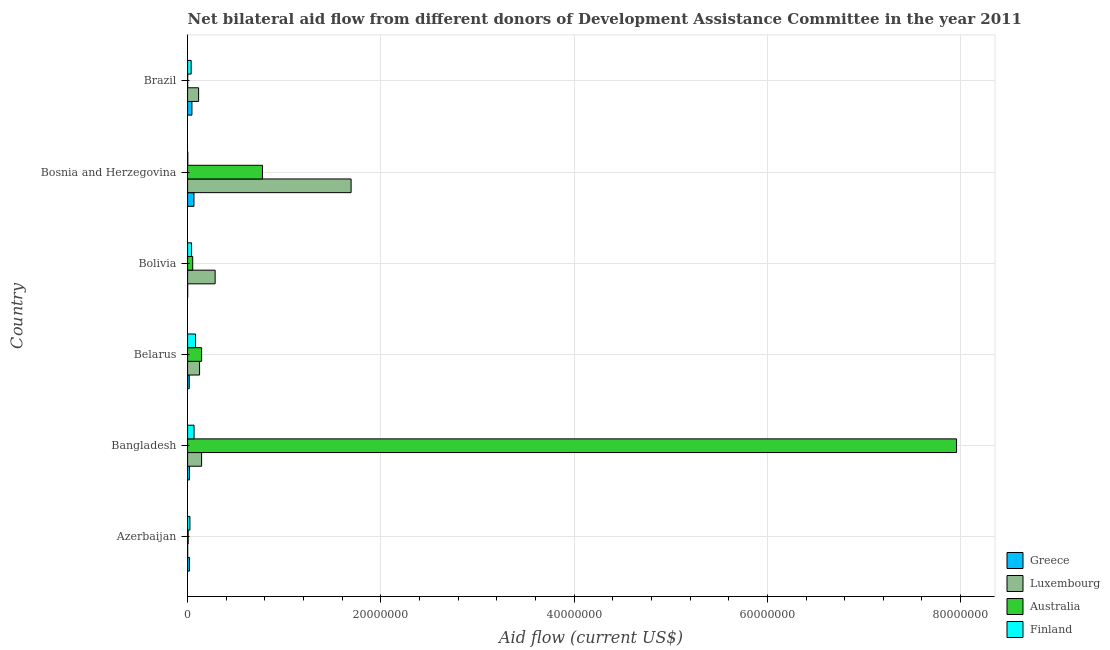How many groups of bars are there?
Your answer should be very brief. 6. Are the number of bars on each tick of the Y-axis equal?
Provide a succinct answer. Yes. How many bars are there on the 3rd tick from the top?
Keep it short and to the point. 4. How many bars are there on the 6th tick from the bottom?
Your response must be concise. 4. What is the label of the 5th group of bars from the top?
Provide a short and direct response. Bangladesh. In how many cases, is the number of bars for a given country not equal to the number of legend labels?
Ensure brevity in your answer.  0. What is the amount of aid given by luxembourg in Belarus?
Ensure brevity in your answer.  1.24e+06. Across all countries, what is the maximum amount of aid given by luxembourg?
Provide a succinct answer. 1.69e+07. Across all countries, what is the minimum amount of aid given by australia?
Ensure brevity in your answer.  10000. What is the total amount of aid given by luxembourg in the graph?
Your answer should be compact. 2.36e+07. What is the difference between the amount of aid given by finland in Bangladesh and that in Bosnia and Herzegovina?
Your answer should be compact. 6.50e+05. What is the difference between the amount of aid given by australia in Bosnia and Herzegovina and the amount of aid given by finland in Belarus?
Provide a succinct answer. 6.93e+06. What is the average amount of aid given by luxembourg per country?
Your response must be concise. 3.94e+06. What is the difference between the amount of aid given by luxembourg and amount of aid given by greece in Azerbaijan?
Ensure brevity in your answer.  -1.80e+05. What is the ratio of the amount of aid given by luxembourg in Bangladesh to that in Bosnia and Herzegovina?
Your answer should be compact. 0.09. Is the amount of aid given by finland in Azerbaijan less than that in Brazil?
Ensure brevity in your answer.  Yes. Is the difference between the amount of aid given by finland in Azerbaijan and Bolivia greater than the difference between the amount of aid given by greece in Azerbaijan and Bolivia?
Your answer should be very brief. No. What is the difference between the highest and the lowest amount of aid given by australia?
Provide a succinct answer. 7.96e+07. In how many countries, is the amount of aid given by luxembourg greater than the average amount of aid given by luxembourg taken over all countries?
Your answer should be very brief. 1. Is the sum of the amount of aid given by greece in Bangladesh and Brazil greater than the maximum amount of aid given by finland across all countries?
Provide a short and direct response. No. Is it the case that in every country, the sum of the amount of aid given by greece and amount of aid given by finland is greater than the sum of amount of aid given by australia and amount of aid given by luxembourg?
Your response must be concise. Yes. What does the 2nd bar from the top in Bosnia and Herzegovina represents?
Your response must be concise. Australia. What does the 1st bar from the bottom in Azerbaijan represents?
Keep it short and to the point. Greece. Is it the case that in every country, the sum of the amount of aid given by greece and amount of aid given by luxembourg is greater than the amount of aid given by australia?
Your response must be concise. No. How many bars are there?
Make the answer very short. 24. How many countries are there in the graph?
Your answer should be compact. 6. What is the difference between two consecutive major ticks on the X-axis?
Ensure brevity in your answer.  2.00e+07. Does the graph contain any zero values?
Make the answer very short. No. Where does the legend appear in the graph?
Your answer should be compact. Bottom right. What is the title of the graph?
Your answer should be compact. Net bilateral aid flow from different donors of Development Assistance Committee in the year 2011. What is the Aid flow (current US$) of Luxembourg in Azerbaijan?
Make the answer very short. 10000. What is the Aid flow (current US$) in Australia in Azerbaijan?
Offer a terse response. 6.00e+04. What is the Aid flow (current US$) of Finland in Azerbaijan?
Give a very brief answer. 2.40e+05. What is the Aid flow (current US$) in Greece in Bangladesh?
Your response must be concise. 2.00e+05. What is the Aid flow (current US$) in Luxembourg in Bangladesh?
Your answer should be compact. 1.45e+06. What is the Aid flow (current US$) of Australia in Bangladesh?
Ensure brevity in your answer.  7.96e+07. What is the Aid flow (current US$) in Finland in Bangladesh?
Offer a terse response. 6.70e+05. What is the Aid flow (current US$) in Luxembourg in Belarus?
Give a very brief answer. 1.24e+06. What is the Aid flow (current US$) in Australia in Belarus?
Your answer should be compact. 1.45e+06. What is the Aid flow (current US$) of Finland in Belarus?
Give a very brief answer. 8.20e+05. What is the Aid flow (current US$) of Greece in Bolivia?
Your response must be concise. 10000. What is the Aid flow (current US$) in Luxembourg in Bolivia?
Give a very brief answer. 2.85e+06. What is the Aid flow (current US$) in Australia in Bolivia?
Your answer should be compact. 5.30e+05. What is the Aid flow (current US$) in Finland in Bolivia?
Keep it short and to the point. 4.10e+05. What is the Aid flow (current US$) in Greece in Bosnia and Herzegovina?
Offer a very short reply. 6.60e+05. What is the Aid flow (current US$) of Luxembourg in Bosnia and Herzegovina?
Offer a very short reply. 1.69e+07. What is the Aid flow (current US$) of Australia in Bosnia and Herzegovina?
Give a very brief answer. 7.75e+06. What is the Aid flow (current US$) in Greece in Brazil?
Provide a succinct answer. 4.50e+05. What is the Aid flow (current US$) in Luxembourg in Brazil?
Offer a very short reply. 1.14e+06. What is the Aid flow (current US$) in Australia in Brazil?
Your answer should be compact. 10000. Across all countries, what is the maximum Aid flow (current US$) of Luxembourg?
Offer a very short reply. 1.69e+07. Across all countries, what is the maximum Aid flow (current US$) of Australia?
Your answer should be compact. 7.96e+07. Across all countries, what is the maximum Aid flow (current US$) in Finland?
Ensure brevity in your answer.  8.20e+05. Across all countries, what is the minimum Aid flow (current US$) in Greece?
Keep it short and to the point. 10000. Across all countries, what is the minimum Aid flow (current US$) in Australia?
Give a very brief answer. 10000. What is the total Aid flow (current US$) in Greece in the graph?
Make the answer very short. 1.68e+06. What is the total Aid flow (current US$) in Luxembourg in the graph?
Keep it short and to the point. 2.36e+07. What is the total Aid flow (current US$) in Australia in the graph?
Your answer should be very brief. 8.94e+07. What is the total Aid flow (current US$) in Finland in the graph?
Your response must be concise. 2.53e+06. What is the difference between the Aid flow (current US$) of Luxembourg in Azerbaijan and that in Bangladesh?
Make the answer very short. -1.44e+06. What is the difference between the Aid flow (current US$) in Australia in Azerbaijan and that in Bangladesh?
Provide a succinct answer. -7.95e+07. What is the difference between the Aid flow (current US$) in Finland in Azerbaijan and that in Bangladesh?
Provide a short and direct response. -4.30e+05. What is the difference between the Aid flow (current US$) of Greece in Azerbaijan and that in Belarus?
Keep it short and to the point. 2.00e+04. What is the difference between the Aid flow (current US$) of Luxembourg in Azerbaijan and that in Belarus?
Offer a terse response. -1.23e+06. What is the difference between the Aid flow (current US$) in Australia in Azerbaijan and that in Belarus?
Offer a very short reply. -1.39e+06. What is the difference between the Aid flow (current US$) of Finland in Azerbaijan and that in Belarus?
Provide a short and direct response. -5.80e+05. What is the difference between the Aid flow (current US$) in Greece in Azerbaijan and that in Bolivia?
Keep it short and to the point. 1.80e+05. What is the difference between the Aid flow (current US$) in Luxembourg in Azerbaijan and that in Bolivia?
Offer a terse response. -2.84e+06. What is the difference between the Aid flow (current US$) in Australia in Azerbaijan and that in Bolivia?
Make the answer very short. -4.70e+05. What is the difference between the Aid flow (current US$) in Finland in Azerbaijan and that in Bolivia?
Offer a terse response. -1.70e+05. What is the difference between the Aid flow (current US$) in Greece in Azerbaijan and that in Bosnia and Herzegovina?
Provide a short and direct response. -4.70e+05. What is the difference between the Aid flow (current US$) of Luxembourg in Azerbaijan and that in Bosnia and Herzegovina?
Provide a succinct answer. -1.69e+07. What is the difference between the Aid flow (current US$) in Australia in Azerbaijan and that in Bosnia and Herzegovina?
Your answer should be very brief. -7.69e+06. What is the difference between the Aid flow (current US$) in Finland in Azerbaijan and that in Bosnia and Herzegovina?
Your answer should be very brief. 2.20e+05. What is the difference between the Aid flow (current US$) in Luxembourg in Azerbaijan and that in Brazil?
Offer a terse response. -1.13e+06. What is the difference between the Aid flow (current US$) in Australia in Azerbaijan and that in Brazil?
Give a very brief answer. 5.00e+04. What is the difference between the Aid flow (current US$) in Greece in Bangladesh and that in Belarus?
Your response must be concise. 3.00e+04. What is the difference between the Aid flow (current US$) of Australia in Bangladesh and that in Belarus?
Provide a succinct answer. 7.81e+07. What is the difference between the Aid flow (current US$) in Greece in Bangladesh and that in Bolivia?
Your answer should be very brief. 1.90e+05. What is the difference between the Aid flow (current US$) of Luxembourg in Bangladesh and that in Bolivia?
Ensure brevity in your answer.  -1.40e+06. What is the difference between the Aid flow (current US$) of Australia in Bangladesh and that in Bolivia?
Offer a very short reply. 7.90e+07. What is the difference between the Aid flow (current US$) of Greece in Bangladesh and that in Bosnia and Herzegovina?
Your response must be concise. -4.60e+05. What is the difference between the Aid flow (current US$) in Luxembourg in Bangladesh and that in Bosnia and Herzegovina?
Make the answer very short. -1.55e+07. What is the difference between the Aid flow (current US$) of Australia in Bangladesh and that in Bosnia and Herzegovina?
Offer a terse response. 7.18e+07. What is the difference between the Aid flow (current US$) in Finland in Bangladesh and that in Bosnia and Herzegovina?
Provide a succinct answer. 6.50e+05. What is the difference between the Aid flow (current US$) in Greece in Bangladesh and that in Brazil?
Your answer should be very brief. -2.50e+05. What is the difference between the Aid flow (current US$) of Luxembourg in Bangladesh and that in Brazil?
Keep it short and to the point. 3.10e+05. What is the difference between the Aid flow (current US$) of Australia in Bangladesh and that in Brazil?
Your answer should be compact. 7.96e+07. What is the difference between the Aid flow (current US$) of Greece in Belarus and that in Bolivia?
Offer a terse response. 1.60e+05. What is the difference between the Aid flow (current US$) in Luxembourg in Belarus and that in Bolivia?
Offer a terse response. -1.61e+06. What is the difference between the Aid flow (current US$) in Australia in Belarus and that in Bolivia?
Ensure brevity in your answer.  9.20e+05. What is the difference between the Aid flow (current US$) of Finland in Belarus and that in Bolivia?
Provide a succinct answer. 4.10e+05. What is the difference between the Aid flow (current US$) in Greece in Belarus and that in Bosnia and Herzegovina?
Offer a terse response. -4.90e+05. What is the difference between the Aid flow (current US$) of Luxembourg in Belarus and that in Bosnia and Herzegovina?
Your answer should be very brief. -1.57e+07. What is the difference between the Aid flow (current US$) of Australia in Belarus and that in Bosnia and Herzegovina?
Provide a short and direct response. -6.30e+06. What is the difference between the Aid flow (current US$) in Finland in Belarus and that in Bosnia and Herzegovina?
Ensure brevity in your answer.  8.00e+05. What is the difference between the Aid flow (current US$) in Greece in Belarus and that in Brazil?
Keep it short and to the point. -2.80e+05. What is the difference between the Aid flow (current US$) in Luxembourg in Belarus and that in Brazil?
Offer a terse response. 1.00e+05. What is the difference between the Aid flow (current US$) of Australia in Belarus and that in Brazil?
Your response must be concise. 1.44e+06. What is the difference between the Aid flow (current US$) of Greece in Bolivia and that in Bosnia and Herzegovina?
Make the answer very short. -6.50e+05. What is the difference between the Aid flow (current US$) of Luxembourg in Bolivia and that in Bosnia and Herzegovina?
Give a very brief answer. -1.41e+07. What is the difference between the Aid flow (current US$) of Australia in Bolivia and that in Bosnia and Herzegovina?
Offer a terse response. -7.22e+06. What is the difference between the Aid flow (current US$) in Greece in Bolivia and that in Brazil?
Keep it short and to the point. -4.40e+05. What is the difference between the Aid flow (current US$) in Luxembourg in Bolivia and that in Brazil?
Make the answer very short. 1.71e+06. What is the difference between the Aid flow (current US$) in Australia in Bolivia and that in Brazil?
Make the answer very short. 5.20e+05. What is the difference between the Aid flow (current US$) in Finland in Bolivia and that in Brazil?
Your response must be concise. 4.00e+04. What is the difference between the Aid flow (current US$) in Greece in Bosnia and Herzegovina and that in Brazil?
Your answer should be very brief. 2.10e+05. What is the difference between the Aid flow (current US$) in Luxembourg in Bosnia and Herzegovina and that in Brazil?
Offer a very short reply. 1.58e+07. What is the difference between the Aid flow (current US$) of Australia in Bosnia and Herzegovina and that in Brazil?
Offer a terse response. 7.74e+06. What is the difference between the Aid flow (current US$) of Finland in Bosnia and Herzegovina and that in Brazil?
Your response must be concise. -3.50e+05. What is the difference between the Aid flow (current US$) in Greece in Azerbaijan and the Aid flow (current US$) in Luxembourg in Bangladesh?
Offer a terse response. -1.26e+06. What is the difference between the Aid flow (current US$) in Greece in Azerbaijan and the Aid flow (current US$) in Australia in Bangladesh?
Make the answer very short. -7.94e+07. What is the difference between the Aid flow (current US$) of Greece in Azerbaijan and the Aid flow (current US$) of Finland in Bangladesh?
Offer a very short reply. -4.80e+05. What is the difference between the Aid flow (current US$) in Luxembourg in Azerbaijan and the Aid flow (current US$) in Australia in Bangladesh?
Offer a very short reply. -7.96e+07. What is the difference between the Aid flow (current US$) of Luxembourg in Azerbaijan and the Aid flow (current US$) of Finland in Bangladesh?
Provide a succinct answer. -6.60e+05. What is the difference between the Aid flow (current US$) of Australia in Azerbaijan and the Aid flow (current US$) of Finland in Bangladesh?
Offer a very short reply. -6.10e+05. What is the difference between the Aid flow (current US$) of Greece in Azerbaijan and the Aid flow (current US$) of Luxembourg in Belarus?
Keep it short and to the point. -1.05e+06. What is the difference between the Aid flow (current US$) of Greece in Azerbaijan and the Aid flow (current US$) of Australia in Belarus?
Make the answer very short. -1.26e+06. What is the difference between the Aid flow (current US$) in Greece in Azerbaijan and the Aid flow (current US$) in Finland in Belarus?
Make the answer very short. -6.30e+05. What is the difference between the Aid flow (current US$) in Luxembourg in Azerbaijan and the Aid flow (current US$) in Australia in Belarus?
Your response must be concise. -1.44e+06. What is the difference between the Aid flow (current US$) in Luxembourg in Azerbaijan and the Aid flow (current US$) in Finland in Belarus?
Keep it short and to the point. -8.10e+05. What is the difference between the Aid flow (current US$) of Australia in Azerbaijan and the Aid flow (current US$) of Finland in Belarus?
Offer a terse response. -7.60e+05. What is the difference between the Aid flow (current US$) in Greece in Azerbaijan and the Aid flow (current US$) in Luxembourg in Bolivia?
Provide a short and direct response. -2.66e+06. What is the difference between the Aid flow (current US$) of Greece in Azerbaijan and the Aid flow (current US$) of Finland in Bolivia?
Offer a very short reply. -2.20e+05. What is the difference between the Aid flow (current US$) in Luxembourg in Azerbaijan and the Aid flow (current US$) in Australia in Bolivia?
Offer a very short reply. -5.20e+05. What is the difference between the Aid flow (current US$) of Luxembourg in Azerbaijan and the Aid flow (current US$) of Finland in Bolivia?
Your answer should be very brief. -4.00e+05. What is the difference between the Aid flow (current US$) of Australia in Azerbaijan and the Aid flow (current US$) of Finland in Bolivia?
Make the answer very short. -3.50e+05. What is the difference between the Aid flow (current US$) in Greece in Azerbaijan and the Aid flow (current US$) in Luxembourg in Bosnia and Herzegovina?
Make the answer very short. -1.67e+07. What is the difference between the Aid flow (current US$) in Greece in Azerbaijan and the Aid flow (current US$) in Australia in Bosnia and Herzegovina?
Your answer should be very brief. -7.56e+06. What is the difference between the Aid flow (current US$) in Greece in Azerbaijan and the Aid flow (current US$) in Finland in Bosnia and Herzegovina?
Offer a very short reply. 1.70e+05. What is the difference between the Aid flow (current US$) in Luxembourg in Azerbaijan and the Aid flow (current US$) in Australia in Bosnia and Herzegovina?
Ensure brevity in your answer.  -7.74e+06. What is the difference between the Aid flow (current US$) in Australia in Azerbaijan and the Aid flow (current US$) in Finland in Bosnia and Herzegovina?
Provide a short and direct response. 4.00e+04. What is the difference between the Aid flow (current US$) of Greece in Azerbaijan and the Aid flow (current US$) of Luxembourg in Brazil?
Keep it short and to the point. -9.50e+05. What is the difference between the Aid flow (current US$) of Greece in Azerbaijan and the Aid flow (current US$) of Australia in Brazil?
Your answer should be very brief. 1.80e+05. What is the difference between the Aid flow (current US$) of Greece in Azerbaijan and the Aid flow (current US$) of Finland in Brazil?
Your response must be concise. -1.80e+05. What is the difference between the Aid flow (current US$) in Luxembourg in Azerbaijan and the Aid flow (current US$) in Finland in Brazil?
Your answer should be very brief. -3.60e+05. What is the difference between the Aid flow (current US$) of Australia in Azerbaijan and the Aid flow (current US$) of Finland in Brazil?
Offer a very short reply. -3.10e+05. What is the difference between the Aid flow (current US$) in Greece in Bangladesh and the Aid flow (current US$) in Luxembourg in Belarus?
Provide a short and direct response. -1.04e+06. What is the difference between the Aid flow (current US$) in Greece in Bangladesh and the Aid flow (current US$) in Australia in Belarus?
Keep it short and to the point. -1.25e+06. What is the difference between the Aid flow (current US$) of Greece in Bangladesh and the Aid flow (current US$) of Finland in Belarus?
Offer a terse response. -6.20e+05. What is the difference between the Aid flow (current US$) in Luxembourg in Bangladesh and the Aid flow (current US$) in Australia in Belarus?
Make the answer very short. 0. What is the difference between the Aid flow (current US$) in Luxembourg in Bangladesh and the Aid flow (current US$) in Finland in Belarus?
Offer a very short reply. 6.30e+05. What is the difference between the Aid flow (current US$) of Australia in Bangladesh and the Aid flow (current US$) of Finland in Belarus?
Give a very brief answer. 7.88e+07. What is the difference between the Aid flow (current US$) of Greece in Bangladesh and the Aid flow (current US$) of Luxembourg in Bolivia?
Your answer should be compact. -2.65e+06. What is the difference between the Aid flow (current US$) in Greece in Bangladesh and the Aid flow (current US$) in Australia in Bolivia?
Ensure brevity in your answer.  -3.30e+05. What is the difference between the Aid flow (current US$) of Greece in Bangladesh and the Aid flow (current US$) of Finland in Bolivia?
Provide a short and direct response. -2.10e+05. What is the difference between the Aid flow (current US$) of Luxembourg in Bangladesh and the Aid flow (current US$) of Australia in Bolivia?
Ensure brevity in your answer.  9.20e+05. What is the difference between the Aid flow (current US$) of Luxembourg in Bangladesh and the Aid flow (current US$) of Finland in Bolivia?
Give a very brief answer. 1.04e+06. What is the difference between the Aid flow (current US$) in Australia in Bangladesh and the Aid flow (current US$) in Finland in Bolivia?
Your response must be concise. 7.92e+07. What is the difference between the Aid flow (current US$) in Greece in Bangladesh and the Aid flow (current US$) in Luxembourg in Bosnia and Herzegovina?
Give a very brief answer. -1.67e+07. What is the difference between the Aid flow (current US$) in Greece in Bangladesh and the Aid flow (current US$) in Australia in Bosnia and Herzegovina?
Provide a short and direct response. -7.55e+06. What is the difference between the Aid flow (current US$) of Greece in Bangladesh and the Aid flow (current US$) of Finland in Bosnia and Herzegovina?
Your answer should be compact. 1.80e+05. What is the difference between the Aid flow (current US$) of Luxembourg in Bangladesh and the Aid flow (current US$) of Australia in Bosnia and Herzegovina?
Provide a short and direct response. -6.30e+06. What is the difference between the Aid flow (current US$) of Luxembourg in Bangladesh and the Aid flow (current US$) of Finland in Bosnia and Herzegovina?
Your answer should be very brief. 1.43e+06. What is the difference between the Aid flow (current US$) of Australia in Bangladesh and the Aid flow (current US$) of Finland in Bosnia and Herzegovina?
Ensure brevity in your answer.  7.96e+07. What is the difference between the Aid flow (current US$) of Greece in Bangladesh and the Aid flow (current US$) of Luxembourg in Brazil?
Offer a terse response. -9.40e+05. What is the difference between the Aid flow (current US$) of Greece in Bangladesh and the Aid flow (current US$) of Finland in Brazil?
Your answer should be very brief. -1.70e+05. What is the difference between the Aid flow (current US$) of Luxembourg in Bangladesh and the Aid flow (current US$) of Australia in Brazil?
Ensure brevity in your answer.  1.44e+06. What is the difference between the Aid flow (current US$) of Luxembourg in Bangladesh and the Aid flow (current US$) of Finland in Brazil?
Your answer should be very brief. 1.08e+06. What is the difference between the Aid flow (current US$) of Australia in Bangladesh and the Aid flow (current US$) of Finland in Brazil?
Offer a terse response. 7.92e+07. What is the difference between the Aid flow (current US$) in Greece in Belarus and the Aid flow (current US$) in Luxembourg in Bolivia?
Your answer should be very brief. -2.68e+06. What is the difference between the Aid flow (current US$) in Greece in Belarus and the Aid flow (current US$) in Australia in Bolivia?
Offer a very short reply. -3.60e+05. What is the difference between the Aid flow (current US$) of Luxembourg in Belarus and the Aid flow (current US$) of Australia in Bolivia?
Keep it short and to the point. 7.10e+05. What is the difference between the Aid flow (current US$) of Luxembourg in Belarus and the Aid flow (current US$) of Finland in Bolivia?
Keep it short and to the point. 8.30e+05. What is the difference between the Aid flow (current US$) in Australia in Belarus and the Aid flow (current US$) in Finland in Bolivia?
Provide a succinct answer. 1.04e+06. What is the difference between the Aid flow (current US$) in Greece in Belarus and the Aid flow (current US$) in Luxembourg in Bosnia and Herzegovina?
Offer a very short reply. -1.68e+07. What is the difference between the Aid flow (current US$) of Greece in Belarus and the Aid flow (current US$) of Australia in Bosnia and Herzegovina?
Offer a very short reply. -7.58e+06. What is the difference between the Aid flow (current US$) of Greece in Belarus and the Aid flow (current US$) of Finland in Bosnia and Herzegovina?
Your answer should be compact. 1.50e+05. What is the difference between the Aid flow (current US$) in Luxembourg in Belarus and the Aid flow (current US$) in Australia in Bosnia and Herzegovina?
Make the answer very short. -6.51e+06. What is the difference between the Aid flow (current US$) in Luxembourg in Belarus and the Aid flow (current US$) in Finland in Bosnia and Herzegovina?
Your answer should be compact. 1.22e+06. What is the difference between the Aid flow (current US$) in Australia in Belarus and the Aid flow (current US$) in Finland in Bosnia and Herzegovina?
Make the answer very short. 1.43e+06. What is the difference between the Aid flow (current US$) of Greece in Belarus and the Aid flow (current US$) of Luxembourg in Brazil?
Your response must be concise. -9.70e+05. What is the difference between the Aid flow (current US$) of Greece in Belarus and the Aid flow (current US$) of Finland in Brazil?
Your answer should be very brief. -2.00e+05. What is the difference between the Aid flow (current US$) in Luxembourg in Belarus and the Aid flow (current US$) in Australia in Brazil?
Provide a succinct answer. 1.23e+06. What is the difference between the Aid flow (current US$) in Luxembourg in Belarus and the Aid flow (current US$) in Finland in Brazil?
Your answer should be very brief. 8.70e+05. What is the difference between the Aid flow (current US$) of Australia in Belarus and the Aid flow (current US$) of Finland in Brazil?
Your answer should be compact. 1.08e+06. What is the difference between the Aid flow (current US$) in Greece in Bolivia and the Aid flow (current US$) in Luxembourg in Bosnia and Herzegovina?
Make the answer very short. -1.69e+07. What is the difference between the Aid flow (current US$) in Greece in Bolivia and the Aid flow (current US$) in Australia in Bosnia and Herzegovina?
Your answer should be compact. -7.74e+06. What is the difference between the Aid flow (current US$) in Luxembourg in Bolivia and the Aid flow (current US$) in Australia in Bosnia and Herzegovina?
Offer a very short reply. -4.90e+06. What is the difference between the Aid flow (current US$) in Luxembourg in Bolivia and the Aid flow (current US$) in Finland in Bosnia and Herzegovina?
Your answer should be compact. 2.83e+06. What is the difference between the Aid flow (current US$) of Australia in Bolivia and the Aid flow (current US$) of Finland in Bosnia and Herzegovina?
Provide a short and direct response. 5.10e+05. What is the difference between the Aid flow (current US$) of Greece in Bolivia and the Aid flow (current US$) of Luxembourg in Brazil?
Your response must be concise. -1.13e+06. What is the difference between the Aid flow (current US$) of Greece in Bolivia and the Aid flow (current US$) of Finland in Brazil?
Keep it short and to the point. -3.60e+05. What is the difference between the Aid flow (current US$) in Luxembourg in Bolivia and the Aid flow (current US$) in Australia in Brazil?
Your answer should be very brief. 2.84e+06. What is the difference between the Aid flow (current US$) in Luxembourg in Bolivia and the Aid flow (current US$) in Finland in Brazil?
Your answer should be very brief. 2.48e+06. What is the difference between the Aid flow (current US$) of Australia in Bolivia and the Aid flow (current US$) of Finland in Brazil?
Give a very brief answer. 1.60e+05. What is the difference between the Aid flow (current US$) of Greece in Bosnia and Herzegovina and the Aid flow (current US$) of Luxembourg in Brazil?
Offer a very short reply. -4.80e+05. What is the difference between the Aid flow (current US$) of Greece in Bosnia and Herzegovina and the Aid flow (current US$) of Australia in Brazil?
Your answer should be very brief. 6.50e+05. What is the difference between the Aid flow (current US$) of Greece in Bosnia and Herzegovina and the Aid flow (current US$) of Finland in Brazil?
Your answer should be very brief. 2.90e+05. What is the difference between the Aid flow (current US$) in Luxembourg in Bosnia and Herzegovina and the Aid flow (current US$) in Australia in Brazil?
Keep it short and to the point. 1.69e+07. What is the difference between the Aid flow (current US$) of Luxembourg in Bosnia and Herzegovina and the Aid flow (current US$) of Finland in Brazil?
Offer a terse response. 1.66e+07. What is the difference between the Aid flow (current US$) in Australia in Bosnia and Herzegovina and the Aid flow (current US$) in Finland in Brazil?
Give a very brief answer. 7.38e+06. What is the average Aid flow (current US$) in Luxembourg per country?
Make the answer very short. 3.94e+06. What is the average Aid flow (current US$) in Australia per country?
Your answer should be compact. 1.49e+07. What is the average Aid flow (current US$) of Finland per country?
Your answer should be very brief. 4.22e+05. What is the difference between the Aid flow (current US$) of Greece and Aid flow (current US$) of Finland in Azerbaijan?
Offer a terse response. -5.00e+04. What is the difference between the Aid flow (current US$) of Luxembourg and Aid flow (current US$) of Finland in Azerbaijan?
Your answer should be very brief. -2.30e+05. What is the difference between the Aid flow (current US$) of Greece and Aid flow (current US$) of Luxembourg in Bangladesh?
Provide a succinct answer. -1.25e+06. What is the difference between the Aid flow (current US$) of Greece and Aid flow (current US$) of Australia in Bangladesh?
Your response must be concise. -7.94e+07. What is the difference between the Aid flow (current US$) in Greece and Aid flow (current US$) in Finland in Bangladesh?
Give a very brief answer. -4.70e+05. What is the difference between the Aid flow (current US$) in Luxembourg and Aid flow (current US$) in Australia in Bangladesh?
Your answer should be compact. -7.81e+07. What is the difference between the Aid flow (current US$) in Luxembourg and Aid flow (current US$) in Finland in Bangladesh?
Offer a very short reply. 7.80e+05. What is the difference between the Aid flow (current US$) of Australia and Aid flow (current US$) of Finland in Bangladesh?
Offer a very short reply. 7.89e+07. What is the difference between the Aid flow (current US$) in Greece and Aid flow (current US$) in Luxembourg in Belarus?
Provide a succinct answer. -1.07e+06. What is the difference between the Aid flow (current US$) in Greece and Aid flow (current US$) in Australia in Belarus?
Your answer should be very brief. -1.28e+06. What is the difference between the Aid flow (current US$) in Greece and Aid flow (current US$) in Finland in Belarus?
Offer a very short reply. -6.50e+05. What is the difference between the Aid flow (current US$) in Luxembourg and Aid flow (current US$) in Finland in Belarus?
Give a very brief answer. 4.20e+05. What is the difference between the Aid flow (current US$) in Australia and Aid flow (current US$) in Finland in Belarus?
Offer a terse response. 6.30e+05. What is the difference between the Aid flow (current US$) in Greece and Aid flow (current US$) in Luxembourg in Bolivia?
Your answer should be very brief. -2.84e+06. What is the difference between the Aid flow (current US$) in Greece and Aid flow (current US$) in Australia in Bolivia?
Your answer should be very brief. -5.20e+05. What is the difference between the Aid flow (current US$) in Greece and Aid flow (current US$) in Finland in Bolivia?
Give a very brief answer. -4.00e+05. What is the difference between the Aid flow (current US$) of Luxembourg and Aid flow (current US$) of Australia in Bolivia?
Give a very brief answer. 2.32e+06. What is the difference between the Aid flow (current US$) in Luxembourg and Aid flow (current US$) in Finland in Bolivia?
Give a very brief answer. 2.44e+06. What is the difference between the Aid flow (current US$) in Australia and Aid flow (current US$) in Finland in Bolivia?
Ensure brevity in your answer.  1.20e+05. What is the difference between the Aid flow (current US$) in Greece and Aid flow (current US$) in Luxembourg in Bosnia and Herzegovina?
Provide a succinct answer. -1.63e+07. What is the difference between the Aid flow (current US$) of Greece and Aid flow (current US$) of Australia in Bosnia and Herzegovina?
Make the answer very short. -7.09e+06. What is the difference between the Aid flow (current US$) of Greece and Aid flow (current US$) of Finland in Bosnia and Herzegovina?
Make the answer very short. 6.40e+05. What is the difference between the Aid flow (current US$) of Luxembourg and Aid flow (current US$) of Australia in Bosnia and Herzegovina?
Provide a succinct answer. 9.17e+06. What is the difference between the Aid flow (current US$) of Luxembourg and Aid flow (current US$) of Finland in Bosnia and Herzegovina?
Your answer should be very brief. 1.69e+07. What is the difference between the Aid flow (current US$) in Australia and Aid flow (current US$) in Finland in Bosnia and Herzegovina?
Make the answer very short. 7.73e+06. What is the difference between the Aid flow (current US$) of Greece and Aid flow (current US$) of Luxembourg in Brazil?
Ensure brevity in your answer.  -6.90e+05. What is the difference between the Aid flow (current US$) in Greece and Aid flow (current US$) in Australia in Brazil?
Ensure brevity in your answer.  4.40e+05. What is the difference between the Aid flow (current US$) in Greece and Aid flow (current US$) in Finland in Brazil?
Provide a short and direct response. 8.00e+04. What is the difference between the Aid flow (current US$) in Luxembourg and Aid flow (current US$) in Australia in Brazil?
Offer a very short reply. 1.13e+06. What is the difference between the Aid flow (current US$) in Luxembourg and Aid flow (current US$) in Finland in Brazil?
Provide a short and direct response. 7.70e+05. What is the difference between the Aid flow (current US$) in Australia and Aid flow (current US$) in Finland in Brazil?
Your response must be concise. -3.60e+05. What is the ratio of the Aid flow (current US$) of Luxembourg in Azerbaijan to that in Bangladesh?
Offer a terse response. 0.01. What is the ratio of the Aid flow (current US$) in Australia in Azerbaijan to that in Bangladesh?
Provide a short and direct response. 0. What is the ratio of the Aid flow (current US$) in Finland in Azerbaijan to that in Bangladesh?
Provide a short and direct response. 0.36. What is the ratio of the Aid flow (current US$) of Greece in Azerbaijan to that in Belarus?
Give a very brief answer. 1.12. What is the ratio of the Aid flow (current US$) in Luxembourg in Azerbaijan to that in Belarus?
Make the answer very short. 0.01. What is the ratio of the Aid flow (current US$) in Australia in Azerbaijan to that in Belarus?
Keep it short and to the point. 0.04. What is the ratio of the Aid flow (current US$) of Finland in Azerbaijan to that in Belarus?
Offer a very short reply. 0.29. What is the ratio of the Aid flow (current US$) in Greece in Azerbaijan to that in Bolivia?
Ensure brevity in your answer.  19. What is the ratio of the Aid flow (current US$) of Luxembourg in Azerbaijan to that in Bolivia?
Your answer should be very brief. 0. What is the ratio of the Aid flow (current US$) in Australia in Azerbaijan to that in Bolivia?
Give a very brief answer. 0.11. What is the ratio of the Aid flow (current US$) in Finland in Azerbaijan to that in Bolivia?
Your answer should be very brief. 0.59. What is the ratio of the Aid flow (current US$) in Greece in Azerbaijan to that in Bosnia and Herzegovina?
Your response must be concise. 0.29. What is the ratio of the Aid flow (current US$) of Luxembourg in Azerbaijan to that in Bosnia and Herzegovina?
Give a very brief answer. 0. What is the ratio of the Aid flow (current US$) in Australia in Azerbaijan to that in Bosnia and Herzegovina?
Offer a terse response. 0.01. What is the ratio of the Aid flow (current US$) of Greece in Azerbaijan to that in Brazil?
Provide a short and direct response. 0.42. What is the ratio of the Aid flow (current US$) in Luxembourg in Azerbaijan to that in Brazil?
Offer a terse response. 0.01. What is the ratio of the Aid flow (current US$) in Australia in Azerbaijan to that in Brazil?
Your response must be concise. 6. What is the ratio of the Aid flow (current US$) in Finland in Azerbaijan to that in Brazil?
Provide a succinct answer. 0.65. What is the ratio of the Aid flow (current US$) in Greece in Bangladesh to that in Belarus?
Provide a short and direct response. 1.18. What is the ratio of the Aid flow (current US$) in Luxembourg in Bangladesh to that in Belarus?
Your response must be concise. 1.17. What is the ratio of the Aid flow (current US$) in Australia in Bangladesh to that in Belarus?
Give a very brief answer. 54.88. What is the ratio of the Aid flow (current US$) in Finland in Bangladesh to that in Belarus?
Provide a succinct answer. 0.82. What is the ratio of the Aid flow (current US$) of Luxembourg in Bangladesh to that in Bolivia?
Provide a short and direct response. 0.51. What is the ratio of the Aid flow (current US$) of Australia in Bangladesh to that in Bolivia?
Offer a very short reply. 150.15. What is the ratio of the Aid flow (current US$) in Finland in Bangladesh to that in Bolivia?
Your answer should be very brief. 1.63. What is the ratio of the Aid flow (current US$) in Greece in Bangladesh to that in Bosnia and Herzegovina?
Keep it short and to the point. 0.3. What is the ratio of the Aid flow (current US$) in Luxembourg in Bangladesh to that in Bosnia and Herzegovina?
Ensure brevity in your answer.  0.09. What is the ratio of the Aid flow (current US$) in Australia in Bangladesh to that in Bosnia and Herzegovina?
Give a very brief answer. 10.27. What is the ratio of the Aid flow (current US$) in Finland in Bangladesh to that in Bosnia and Herzegovina?
Give a very brief answer. 33.5. What is the ratio of the Aid flow (current US$) of Greece in Bangladesh to that in Brazil?
Provide a short and direct response. 0.44. What is the ratio of the Aid flow (current US$) of Luxembourg in Bangladesh to that in Brazil?
Give a very brief answer. 1.27. What is the ratio of the Aid flow (current US$) in Australia in Bangladesh to that in Brazil?
Your answer should be very brief. 7958. What is the ratio of the Aid flow (current US$) in Finland in Bangladesh to that in Brazil?
Offer a terse response. 1.81. What is the ratio of the Aid flow (current US$) in Luxembourg in Belarus to that in Bolivia?
Provide a succinct answer. 0.44. What is the ratio of the Aid flow (current US$) of Australia in Belarus to that in Bolivia?
Provide a short and direct response. 2.74. What is the ratio of the Aid flow (current US$) of Finland in Belarus to that in Bolivia?
Give a very brief answer. 2. What is the ratio of the Aid flow (current US$) in Greece in Belarus to that in Bosnia and Herzegovina?
Keep it short and to the point. 0.26. What is the ratio of the Aid flow (current US$) of Luxembourg in Belarus to that in Bosnia and Herzegovina?
Offer a terse response. 0.07. What is the ratio of the Aid flow (current US$) of Australia in Belarus to that in Bosnia and Herzegovina?
Your answer should be compact. 0.19. What is the ratio of the Aid flow (current US$) in Greece in Belarus to that in Brazil?
Offer a terse response. 0.38. What is the ratio of the Aid flow (current US$) of Luxembourg in Belarus to that in Brazil?
Ensure brevity in your answer.  1.09. What is the ratio of the Aid flow (current US$) of Australia in Belarus to that in Brazil?
Offer a very short reply. 145. What is the ratio of the Aid flow (current US$) in Finland in Belarus to that in Brazil?
Make the answer very short. 2.22. What is the ratio of the Aid flow (current US$) in Greece in Bolivia to that in Bosnia and Herzegovina?
Keep it short and to the point. 0.02. What is the ratio of the Aid flow (current US$) of Luxembourg in Bolivia to that in Bosnia and Herzegovina?
Keep it short and to the point. 0.17. What is the ratio of the Aid flow (current US$) in Australia in Bolivia to that in Bosnia and Herzegovina?
Make the answer very short. 0.07. What is the ratio of the Aid flow (current US$) in Finland in Bolivia to that in Bosnia and Herzegovina?
Provide a short and direct response. 20.5. What is the ratio of the Aid flow (current US$) of Greece in Bolivia to that in Brazil?
Offer a terse response. 0.02. What is the ratio of the Aid flow (current US$) in Australia in Bolivia to that in Brazil?
Keep it short and to the point. 53. What is the ratio of the Aid flow (current US$) of Finland in Bolivia to that in Brazil?
Your answer should be compact. 1.11. What is the ratio of the Aid flow (current US$) of Greece in Bosnia and Herzegovina to that in Brazil?
Ensure brevity in your answer.  1.47. What is the ratio of the Aid flow (current US$) in Luxembourg in Bosnia and Herzegovina to that in Brazil?
Make the answer very short. 14.84. What is the ratio of the Aid flow (current US$) in Australia in Bosnia and Herzegovina to that in Brazil?
Provide a succinct answer. 775. What is the ratio of the Aid flow (current US$) of Finland in Bosnia and Herzegovina to that in Brazil?
Your answer should be compact. 0.05. What is the difference between the highest and the second highest Aid flow (current US$) in Greece?
Give a very brief answer. 2.10e+05. What is the difference between the highest and the second highest Aid flow (current US$) of Luxembourg?
Ensure brevity in your answer.  1.41e+07. What is the difference between the highest and the second highest Aid flow (current US$) of Australia?
Your answer should be compact. 7.18e+07. What is the difference between the highest and the lowest Aid flow (current US$) of Greece?
Ensure brevity in your answer.  6.50e+05. What is the difference between the highest and the lowest Aid flow (current US$) of Luxembourg?
Your answer should be very brief. 1.69e+07. What is the difference between the highest and the lowest Aid flow (current US$) of Australia?
Ensure brevity in your answer.  7.96e+07. What is the difference between the highest and the lowest Aid flow (current US$) in Finland?
Keep it short and to the point. 8.00e+05. 